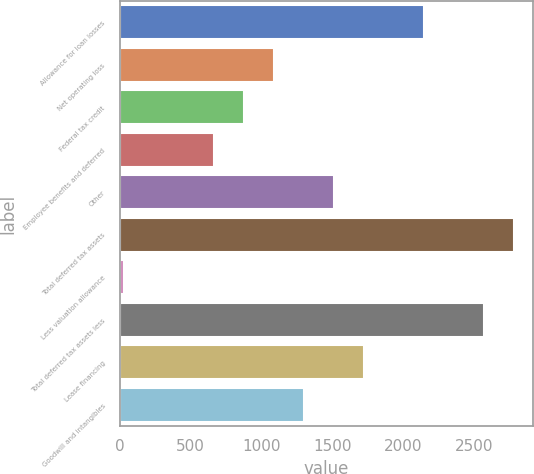Convert chart. <chart><loc_0><loc_0><loc_500><loc_500><bar_chart><fcel>Allowance for loan losses<fcel>Net operating loss<fcel>Federal tax credit<fcel>Employee benefits and deferred<fcel>Other<fcel>Total deferred tax assets<fcel>Less valuation allowance<fcel>Total deferred tax assets less<fcel>Lease financing<fcel>Goodwill and intangibles<nl><fcel>2143<fcel>1086.5<fcel>875.2<fcel>663.9<fcel>1509.1<fcel>2776.9<fcel>30<fcel>2565.6<fcel>1720.4<fcel>1297.8<nl></chart> 